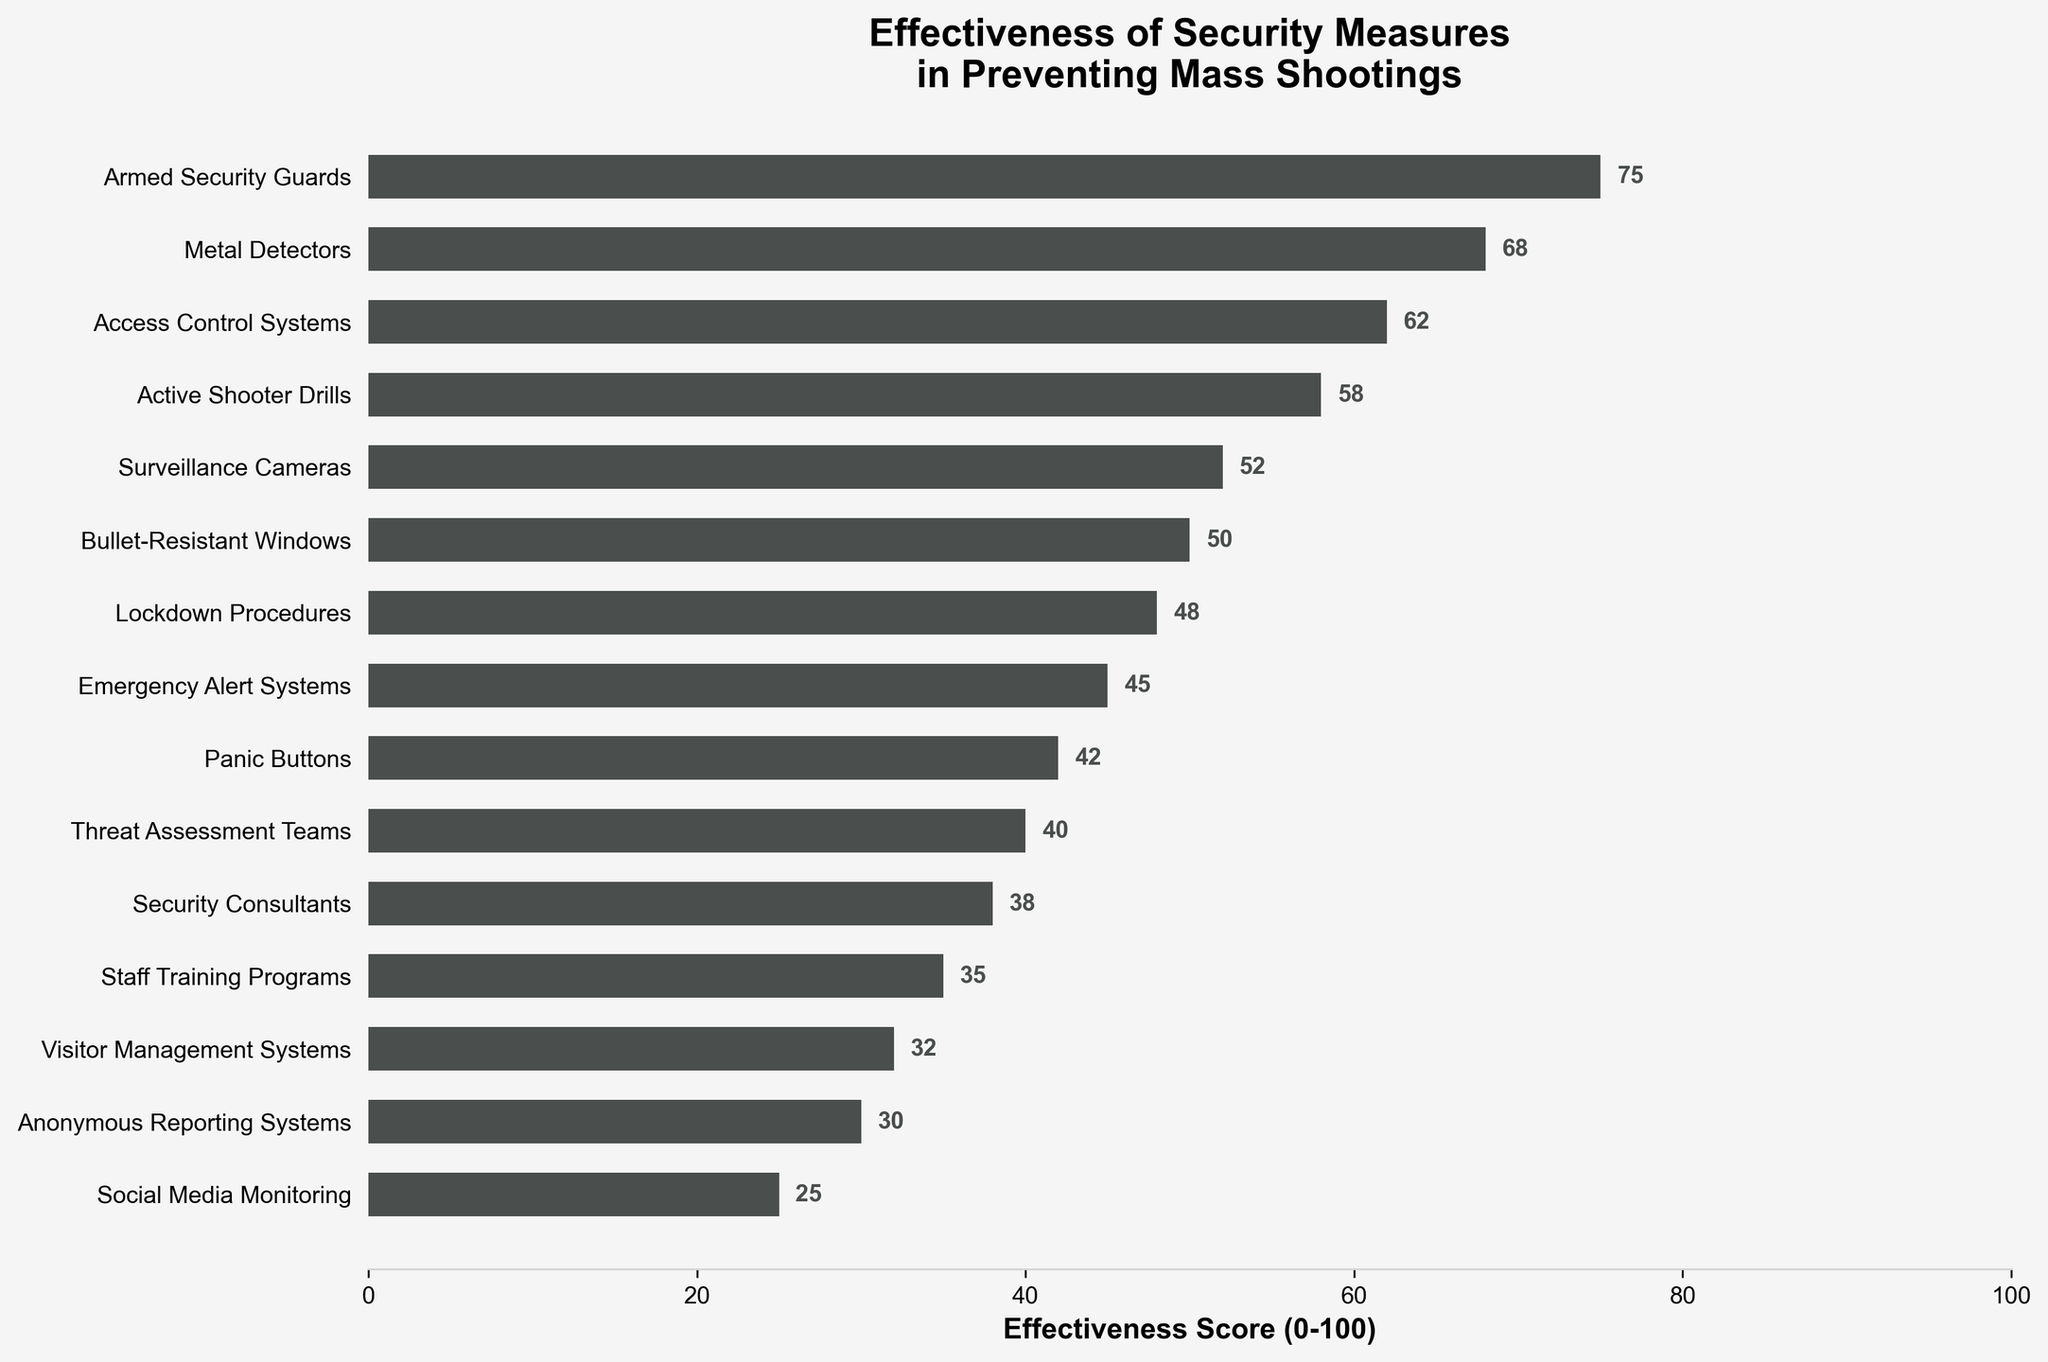How many security measures have an effectiveness score greater than 50? To find the number of security measures with an effectiveness score greater than 50, count all the measures with scores above 50. These measures are Armed Security Guards, Metal Detectors, Access Control Systems, and Active Shooter Drills with scores of 75, 68, 62, and 58 respectively.
Answer: 4 Which security measure has the highest effectiveness score? Identify the security measure with the highest effectiveness score. Armed Security Guards have the highest score at 75.
Answer: Armed Security Guards What is the difference in effectiveness score between Metal Detectors and Panic Buttons? Metal Detectors have a score of 68 and Panic Buttons have a score of 42. Subtract the score of Panic Buttons from Metal Detectors (68 - 42).
Answer: 26 Are there any security measures with an effectiveness score exactly equal to 50? Check the effectiveness scores for a value of 50. Bullet-Resistant Windows have a score of 50.
Answer: Yes What is the average effectiveness score of the top three security measures? The top three measures are Armed Security Guards (75), Metal Detectors (68), and Access Control Systems (62). Sum these values (75 + 68 + 62 = 205) and divide by 3 to get the average.
Answer: 68.33 Which security measure has the lowest effectiveness score? Identify the security measure with the lowest effectiveness score. Social Media Monitoring has the lowest score at 25.
Answer: Social Media Monitoring How many security measures have an effectiveness score below 40? Count the number of security measures with scores below 40. These measures are Security Consultants, Staff Training Programs, Visitor Management Systems, Anonymous Reporting Systems, and Social Media Monitoring with scores of 38, 35, 32, 30, and 25 respectively.
Answer: 5 Is the effectiveness score of Lockdown Procedures greater than that of Threat Assessment Teams? Compare the effectiveness scores of Lockdown Procedures (48) and Threat Assessment Teams (40). Since 48 is greater than 40, yes, it is greater.
Answer: Yes What is the sum of the effectiveness scores for Surveillance Cameras and Emergency Alert Systems? Add the effectiveness scores of Surveillance Cameras (52) and Emergency Alert Systems (45) to find the sum. (52 + 45 = 97).
Answer: 97 